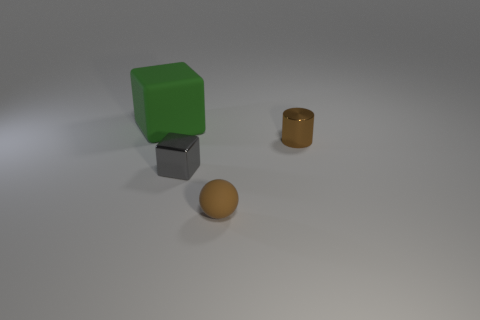Add 3 big cubes. How many objects exist? 7 Subtract all cylinders. How many objects are left? 3 Subtract all yellow blocks. How many cyan balls are left? 0 Subtract all large green objects. Subtract all gray shiny cubes. How many objects are left? 2 Add 4 tiny metallic cylinders. How many tiny metallic cylinders are left? 5 Add 4 cyan rubber balls. How many cyan rubber balls exist? 4 Subtract 0 red cylinders. How many objects are left? 4 Subtract 1 balls. How many balls are left? 0 Subtract all cyan blocks. Subtract all gray cylinders. How many blocks are left? 2 